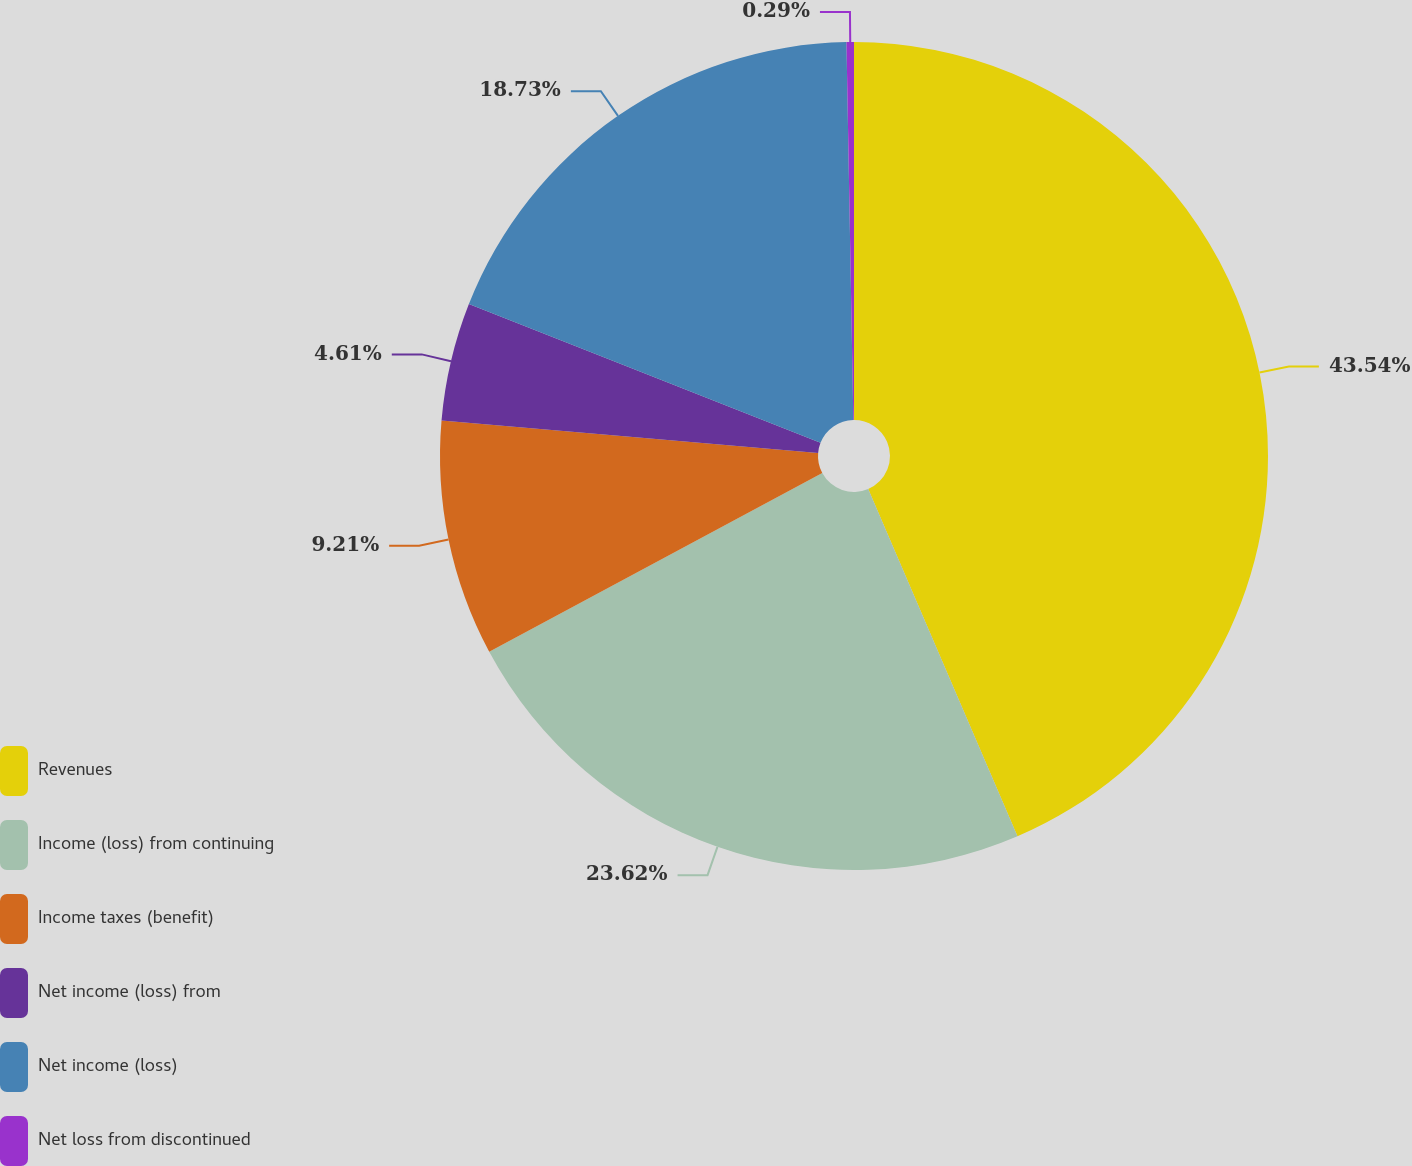<chart> <loc_0><loc_0><loc_500><loc_500><pie_chart><fcel>Revenues<fcel>Income (loss) from continuing<fcel>Income taxes (benefit)<fcel>Net income (loss) from<fcel>Net income (loss)<fcel>Net loss from discontinued<nl><fcel>43.54%<fcel>23.62%<fcel>9.21%<fcel>4.61%<fcel>18.73%<fcel>0.29%<nl></chart> 